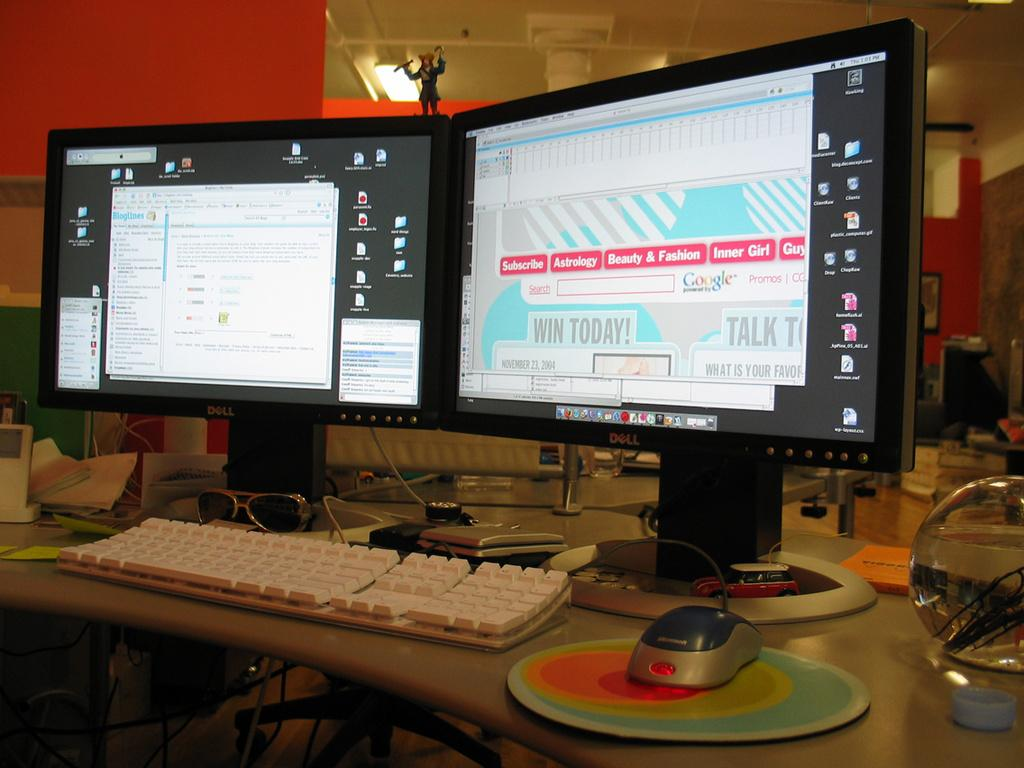<image>
Present a compact description of the photo's key features. Two monitors side by side and the right one shows a google search bar 